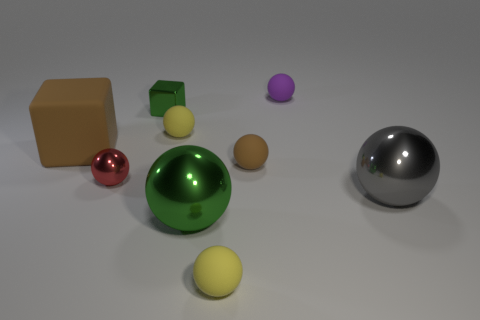Subtract all big green balls. How many balls are left? 6 Add 1 green metal objects. How many objects exist? 10 Subtract all green cubes. How many cubes are left? 1 Subtract all spheres. How many objects are left? 2 Subtract 4 spheres. How many spheres are left? 3 Add 7 red spheres. How many red spheres are left? 8 Add 8 big cyan blocks. How many big cyan blocks exist? 8 Subtract 0 red cylinders. How many objects are left? 9 Subtract all green blocks. Subtract all gray cylinders. How many blocks are left? 1 Subtract all green cylinders. How many yellow balls are left? 2 